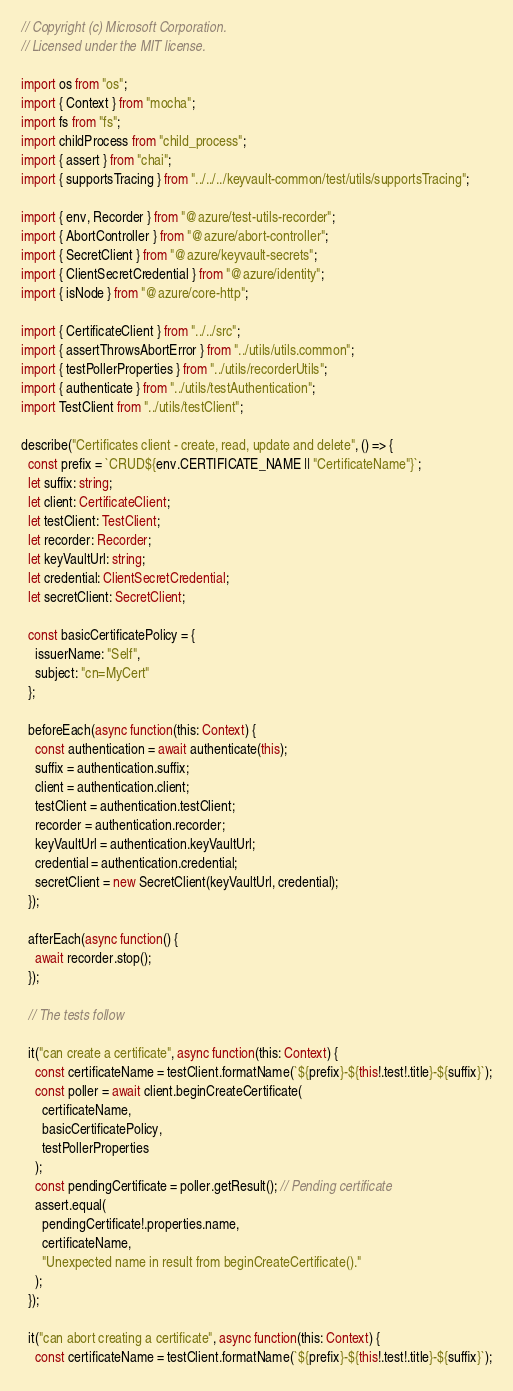<code> <loc_0><loc_0><loc_500><loc_500><_TypeScript_>// Copyright (c) Microsoft Corporation.
// Licensed under the MIT license.

import os from "os";
import { Context } from "mocha";
import fs from "fs";
import childProcess from "child_process";
import { assert } from "chai";
import { supportsTracing } from "../../../keyvault-common/test/utils/supportsTracing";

import { env, Recorder } from "@azure/test-utils-recorder";
import { AbortController } from "@azure/abort-controller";
import { SecretClient } from "@azure/keyvault-secrets";
import { ClientSecretCredential } from "@azure/identity";
import { isNode } from "@azure/core-http";

import { CertificateClient } from "../../src";
import { assertThrowsAbortError } from "../utils/utils.common";
import { testPollerProperties } from "../utils/recorderUtils";
import { authenticate } from "../utils/testAuthentication";
import TestClient from "../utils/testClient";

describe("Certificates client - create, read, update and delete", () => {
  const prefix = `CRUD${env.CERTIFICATE_NAME || "CertificateName"}`;
  let suffix: string;
  let client: CertificateClient;
  let testClient: TestClient;
  let recorder: Recorder;
  let keyVaultUrl: string;
  let credential: ClientSecretCredential;
  let secretClient: SecretClient;

  const basicCertificatePolicy = {
    issuerName: "Self",
    subject: "cn=MyCert"
  };

  beforeEach(async function(this: Context) {
    const authentication = await authenticate(this);
    suffix = authentication.suffix;
    client = authentication.client;
    testClient = authentication.testClient;
    recorder = authentication.recorder;
    keyVaultUrl = authentication.keyVaultUrl;
    credential = authentication.credential;
    secretClient = new SecretClient(keyVaultUrl, credential);
  });

  afterEach(async function() {
    await recorder.stop();
  });

  // The tests follow

  it("can create a certificate", async function(this: Context) {
    const certificateName = testClient.formatName(`${prefix}-${this!.test!.title}-${suffix}`);
    const poller = await client.beginCreateCertificate(
      certificateName,
      basicCertificatePolicy,
      testPollerProperties
    );
    const pendingCertificate = poller.getResult(); // Pending certificate
    assert.equal(
      pendingCertificate!.properties.name,
      certificateName,
      "Unexpected name in result from beginCreateCertificate()."
    );
  });

  it("can abort creating a certificate", async function(this: Context) {
    const certificateName = testClient.formatName(`${prefix}-${this!.test!.title}-${suffix}`);</code> 